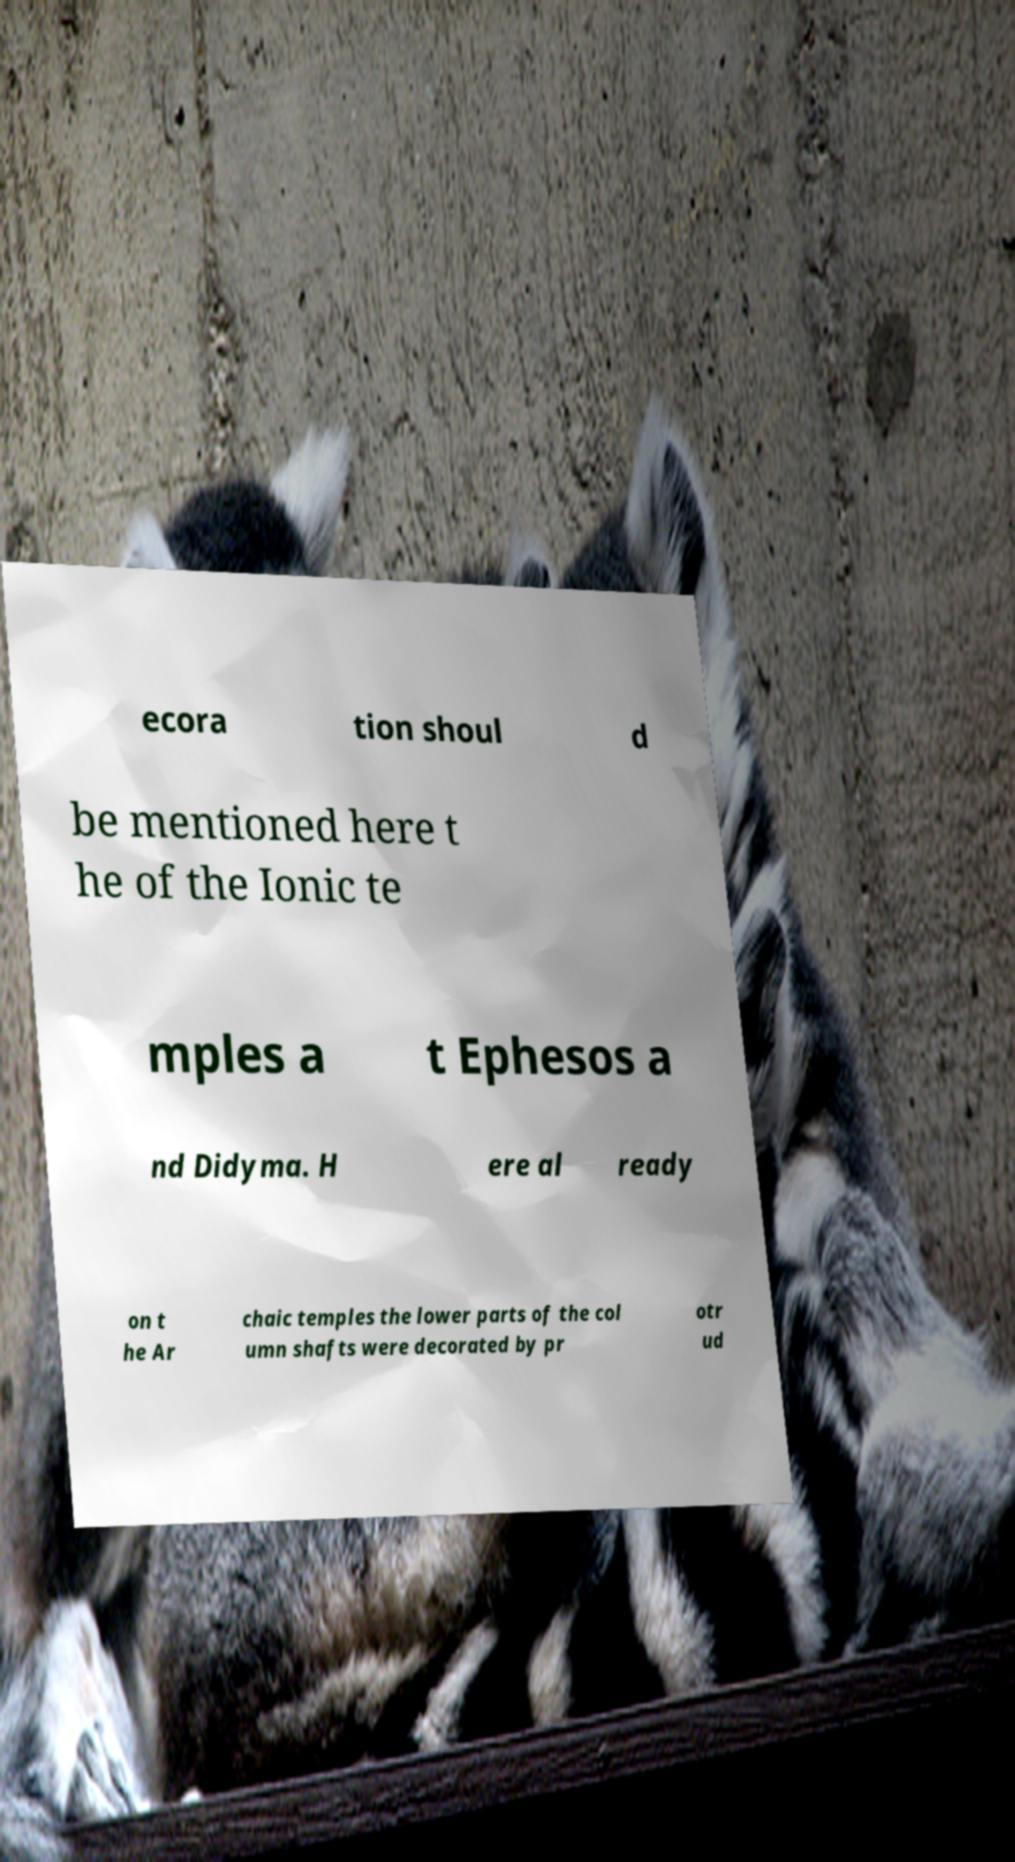Can you accurately transcribe the text from the provided image for me? ecora tion shoul d be mentioned here t he of the Ionic te mples a t Ephesos a nd Didyma. H ere al ready on t he Ar chaic temples the lower parts of the col umn shafts were decorated by pr otr ud 